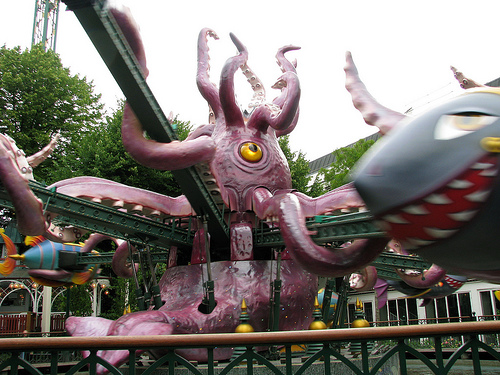<image>
Is the fence in front of the amusement ride? Yes. The fence is positioned in front of the amusement ride, appearing closer to the camera viewpoint. Is there a octopus above the fence? Yes. The octopus is positioned above the fence in the vertical space, higher up in the scene. 